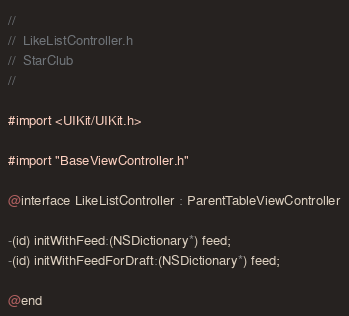Convert code to text. <code><loc_0><loc_0><loc_500><loc_500><_C_>//
//  LikeListController.h
//  StarClub
//

#import <UIKit/UIKit.h>

#import "BaseViewController.h"

@interface LikeListController : ParentTableViewController

-(id) initWithFeed:(NSDictionary*) feed;
-(id) initWithFeedForDraft:(NSDictionary*) feed;

@end
</code> 